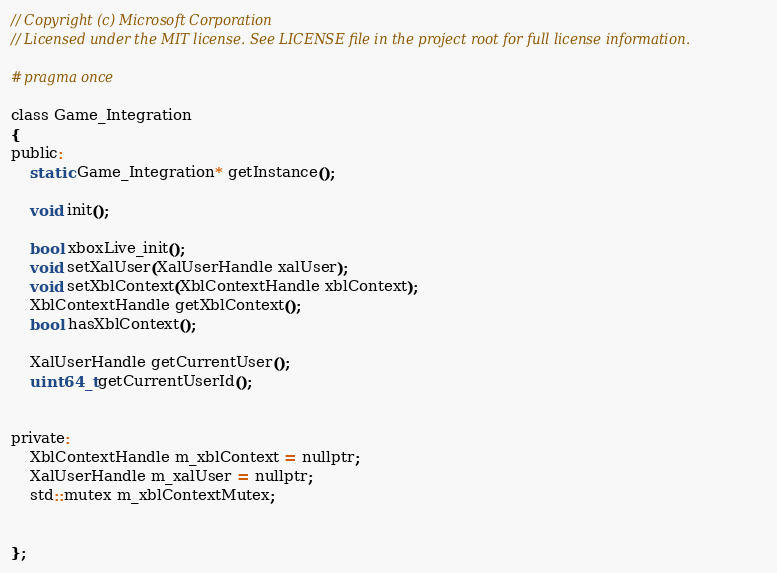Convert code to text. <code><loc_0><loc_0><loc_500><loc_500><_C_>// Copyright (c) Microsoft Corporation
// Licensed under the MIT license. See LICENSE file in the project root for full license information.

#pragma once

class Game_Integration
{
public:
    static Game_Integration* getInstance();
    
    void init();
    
    bool xboxLive_init();
    void setXalUser(XalUserHandle xalUser);
    void setXblContext(XblContextHandle xblContext);
    XblContextHandle getXblContext();
    bool hasXblContext();
    
    XalUserHandle getCurrentUser();
    uint64_t getCurrentUserId();
    

private:
    XblContextHandle m_xblContext = nullptr;
    XalUserHandle m_xalUser = nullptr;
    std::mutex m_xblContextMutex;
    

};
</code> 